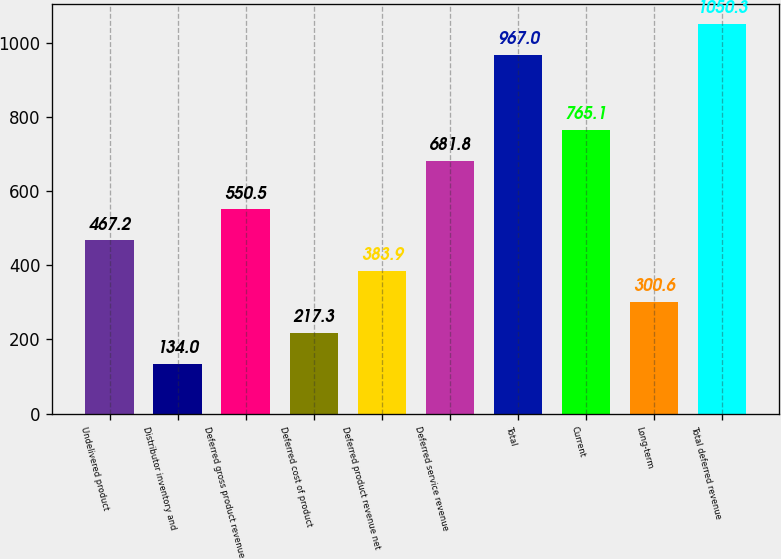Convert chart to OTSL. <chart><loc_0><loc_0><loc_500><loc_500><bar_chart><fcel>Undelivered product<fcel>Distributor inventory and<fcel>Deferred gross product revenue<fcel>Deferred cost of product<fcel>Deferred product revenue net<fcel>Deferred service revenue<fcel>Total<fcel>Current<fcel>Long-term<fcel>Total deferred revenue<nl><fcel>467.2<fcel>134<fcel>550.5<fcel>217.3<fcel>383.9<fcel>681.8<fcel>967<fcel>765.1<fcel>300.6<fcel>1050.3<nl></chart> 